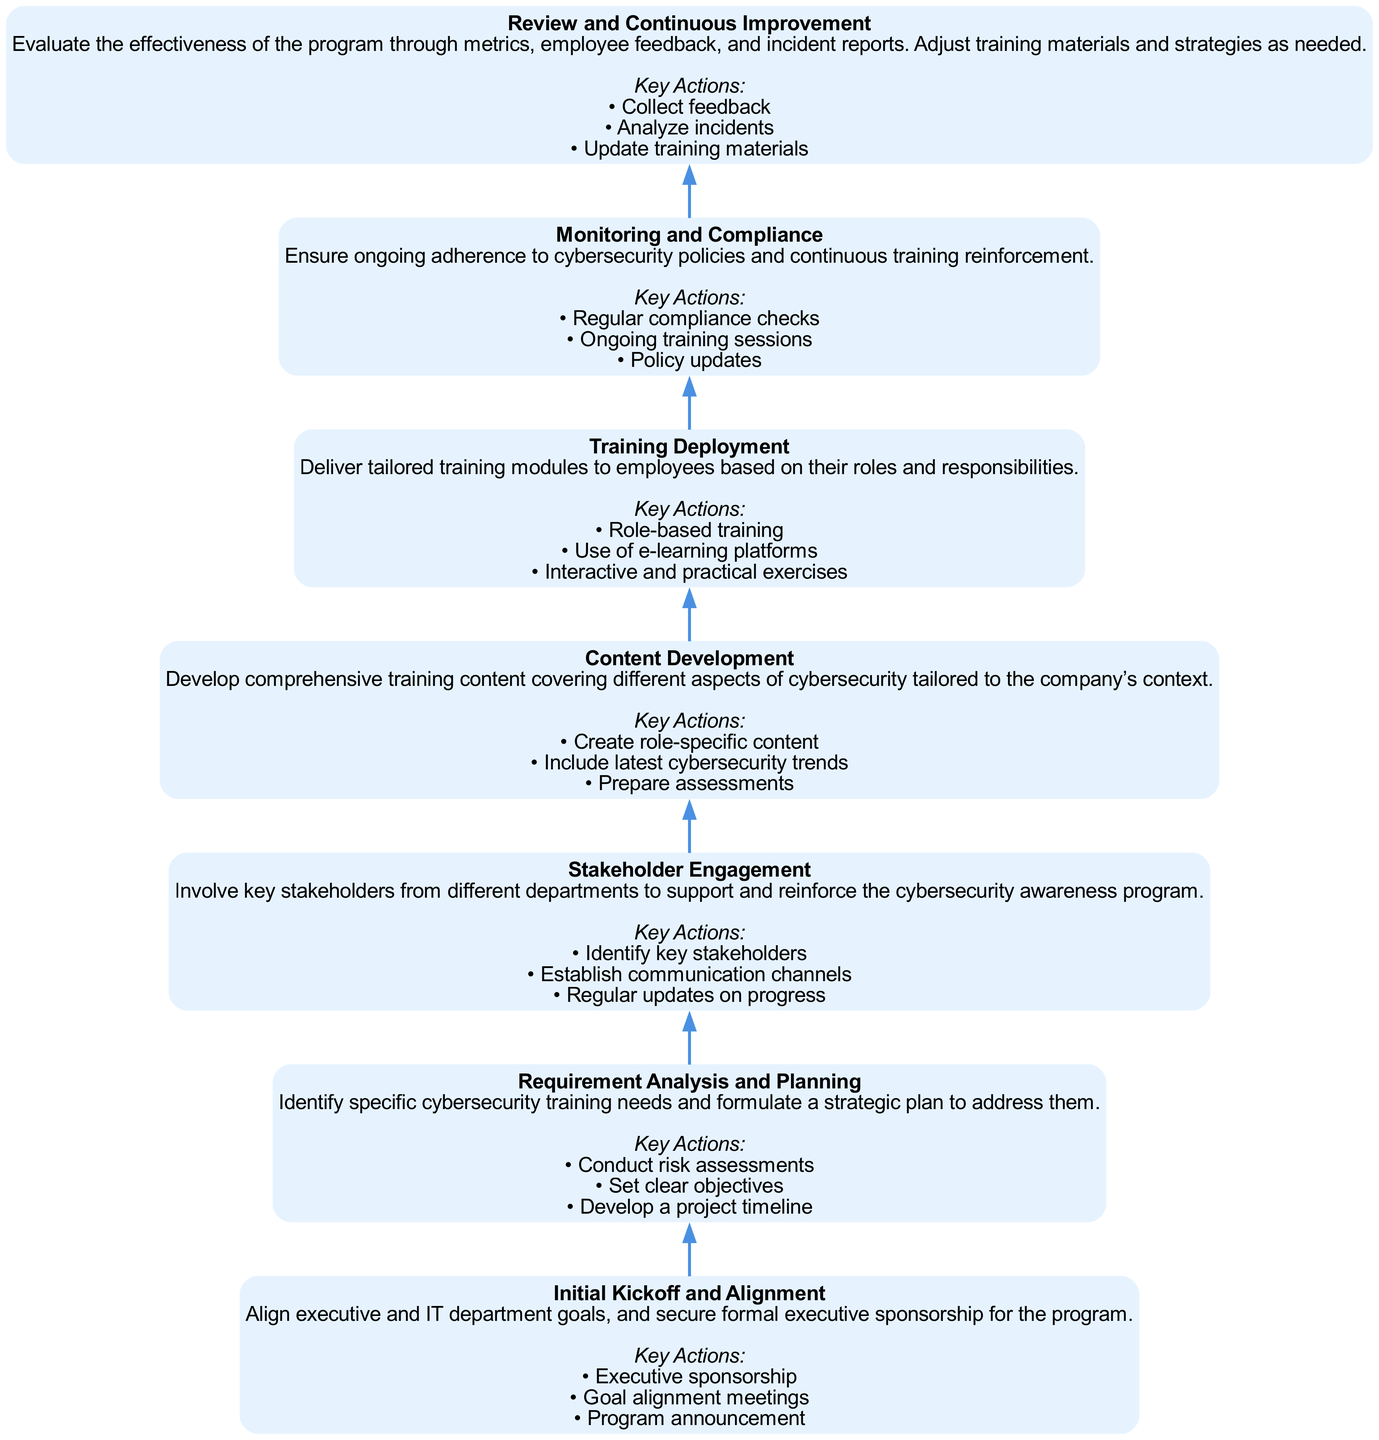What is the final stage in the program rollout? The last stage listed in the flow chart is "Review and Continuous Improvement." This is located at the top of the diagram, indicating it is the final step.
Answer: Review and Continuous Improvement How many key actions are in the "Content Development" stage? By reviewing the "Content Development" stage, we see that there are three key actions listed: "Create role-specific content," "Include latest cybersecurity trends," and "Prepare assessments."
Answer: 3 What is the purpose of the "Initial Kickoff and Alignment" stage? This stage's description clarifies that its purpose is to align executive and IT department goals and secure formal executive sponsorship for the program, making it foundational for program support.
Answer: Align executive and IT department goals Which stage follows "Requirement Analysis and Planning"? By examining the flow from bottom to top, we can see that "Stakeholder Engagement" immediately follows "Requirement Analysis and Planning," indicating that it is the next step in the process.
Answer: Stakeholder Engagement How many stages are included in the entire training program rollout? Counting all the distinct stages listed in the diagram reveals there are a total of seven stages, which encompass the entire process from initial kickoff to review.
Answer: 7 What is the first action listed in the "Monitoring and Compliance" stage? The first action in this node is "Regular compliance checks," as listed in the section detailing key actions for that stage, establishing ongoing training reinforcement.
Answer: Regular compliance checks Why is "Stakeholder Engagement" important in the training rollout process? The description for "Stakeholder Engagement" states that it involves key stakeholders from different departments to support and reinforce the cybersecurity awareness program, which is essential for its effectiveness and acceptance.
Answer: Support and reinforce the program Which stages are involved in the deployment of training? The stages involved in deployment are "Training Deployment" and "Content Development," as they work together to deliver tailored training modules and develop comprehensive training content, respectively.
Answer: Training Deployment and Content Development What is a key action of the "Training Deployment" stage? One of the key actions listed for "Training Deployment" is "Role-based training." This indicates an approach tailored to the specific needs of different employee roles during the training process.
Answer: Role-based training 